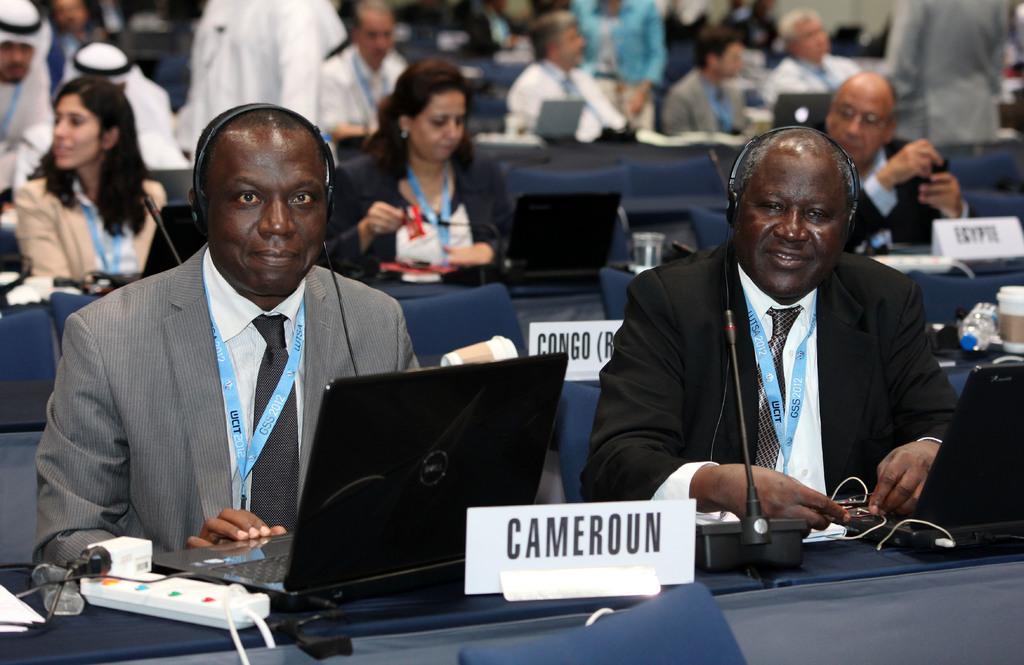Can you describe this image briefly? This is an inside view. Here I can see many people are sitting on the chairs in front of the tables. Here two men are wearing headsets and smiling by looking at the picture. On the tables there are many laptops, microphones, name boards, cables, glasses and other objects. In the background there are two persons standing. 